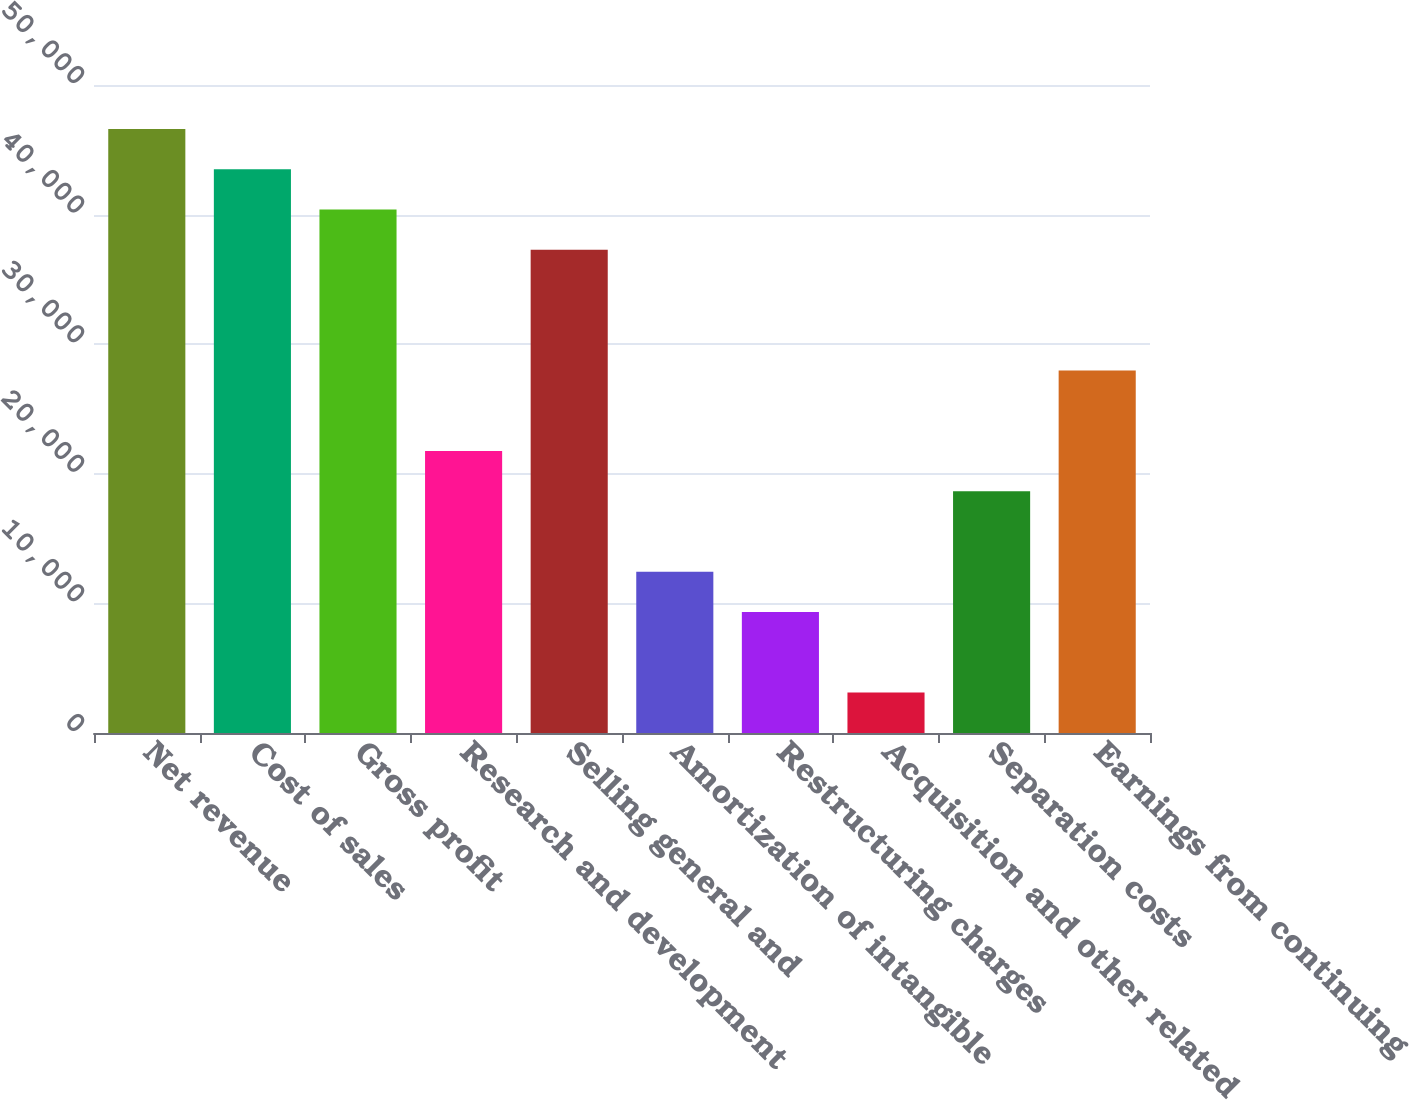Convert chart. <chart><loc_0><loc_0><loc_500><loc_500><bar_chart><fcel>Net revenue<fcel>Cost of sales<fcel>Gross profit<fcel>Research and development<fcel>Selling general and<fcel>Amortization of intangible<fcel>Restructuring charges<fcel>Acquisition and other related<fcel>Separation costs<fcel>Earnings from continuing<nl><fcel>46611<fcel>43504.2<fcel>40397.4<fcel>21756.6<fcel>37290.6<fcel>12436.2<fcel>9329.4<fcel>3115.8<fcel>18649.8<fcel>27970.2<nl></chart> 